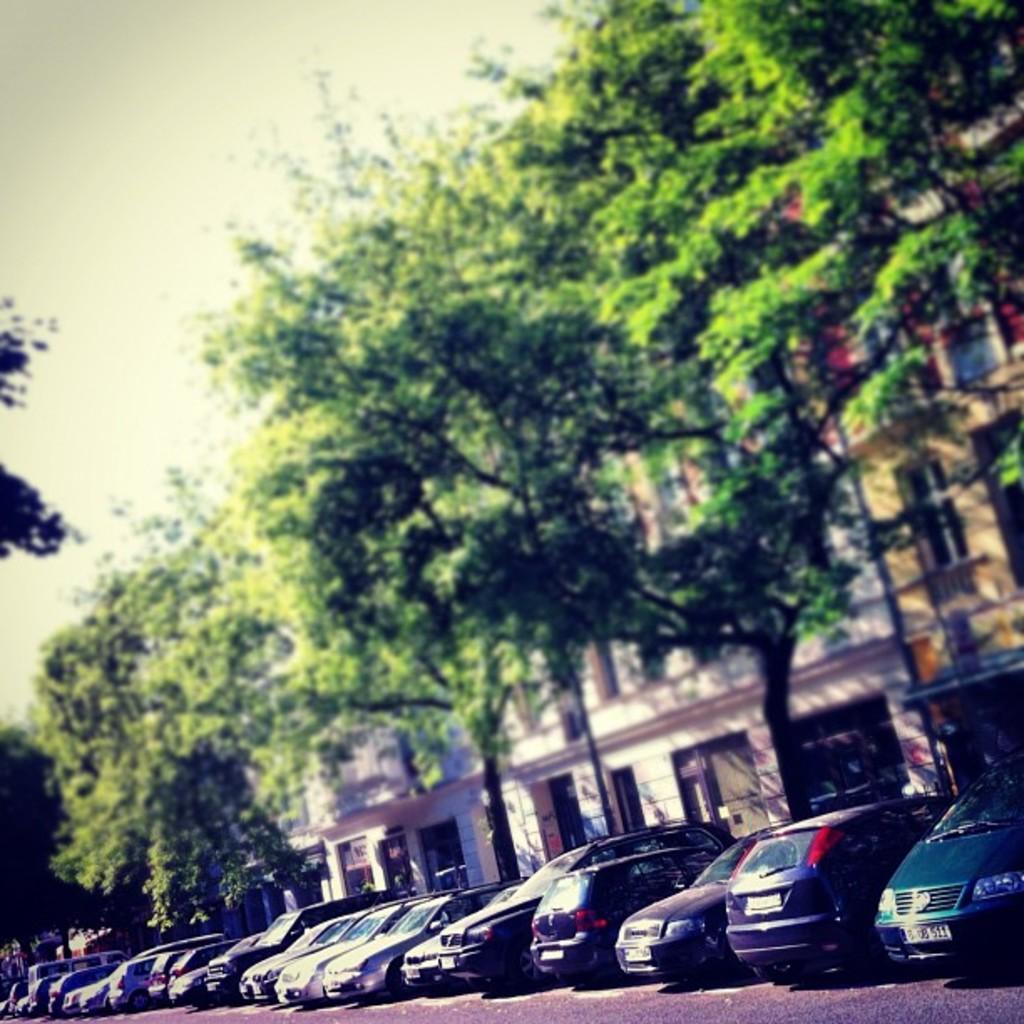Can you describe this image briefly? In the center of the image we can see a few vehicles. In the background, we can see the sky, trees and buildings. 